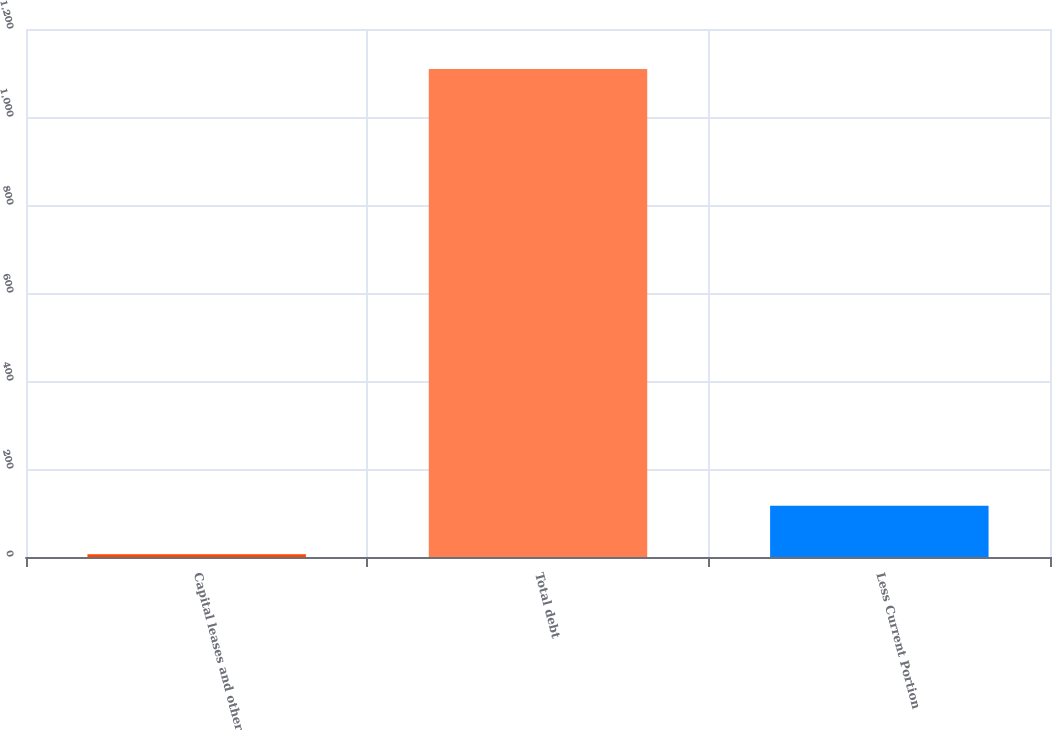<chart> <loc_0><loc_0><loc_500><loc_500><bar_chart><fcel>Capital leases and other<fcel>Total debt<fcel>Less Current Portion<nl><fcel>6.1<fcel>1109.1<fcel>116.4<nl></chart> 